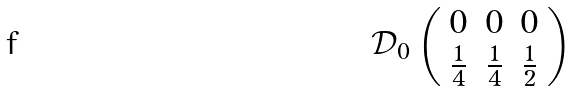<formula> <loc_0><loc_0><loc_500><loc_500>\mathcal { D } _ { 0 } \left ( \begin{array} { c c c } { 0 } & { 0 } & { 0 } \\ { { \frac { 1 } { 4 } } } & { { \frac { 1 } { 4 } } } & { { \frac { 1 } { 2 } } } \end{array} \right )</formula> 